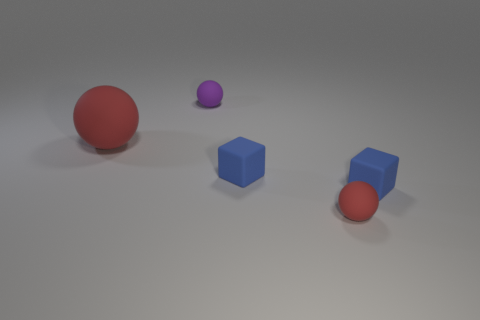What is the relative size of the purple ball compared to the other objects? The purple ball is smaller than the red rubber ball and the blue cube but larger than the tiny blue cylinders. 